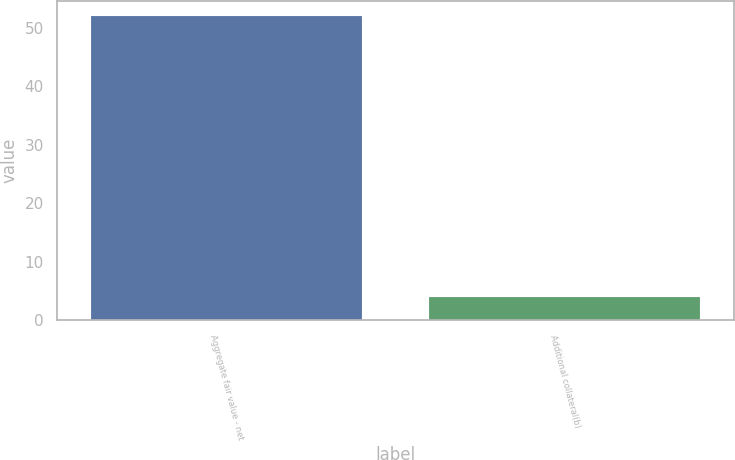<chart> <loc_0><loc_0><loc_500><loc_500><bar_chart><fcel>Aggregate fair value - net<fcel>Additional collateral(b)<nl><fcel>52<fcel>4<nl></chart> 